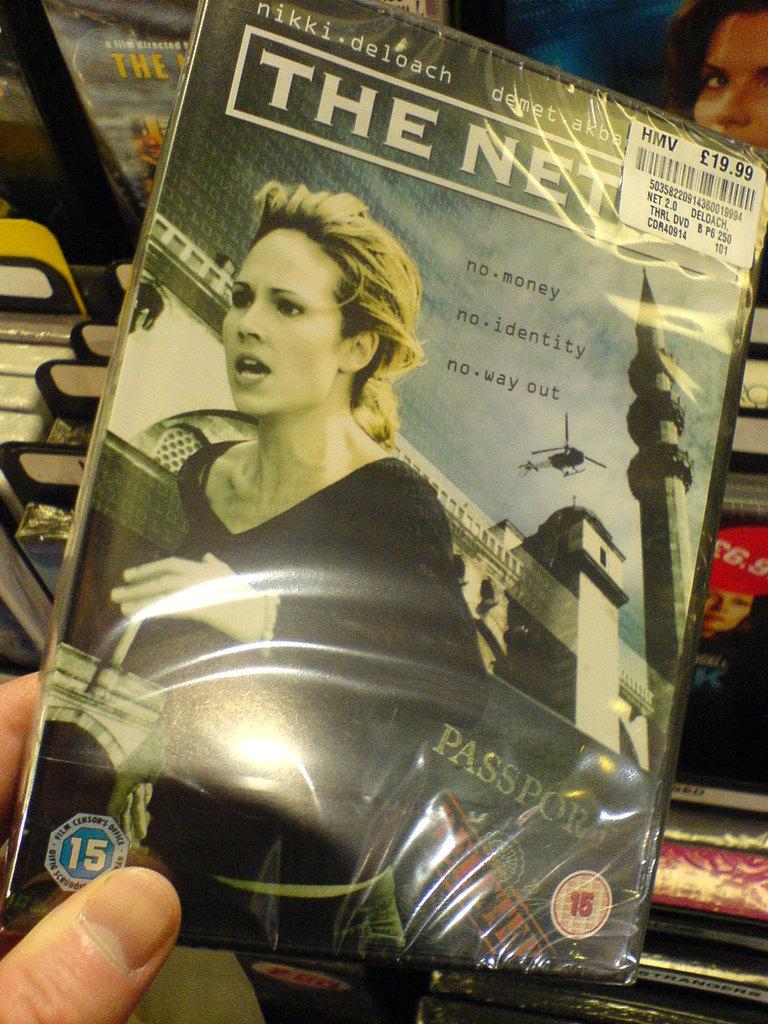Who's the actor on the dvd?
Keep it short and to the point. Nikki deloach. What is the tagline for this movie?
Your answer should be very brief. No money, no identity, no way out. 